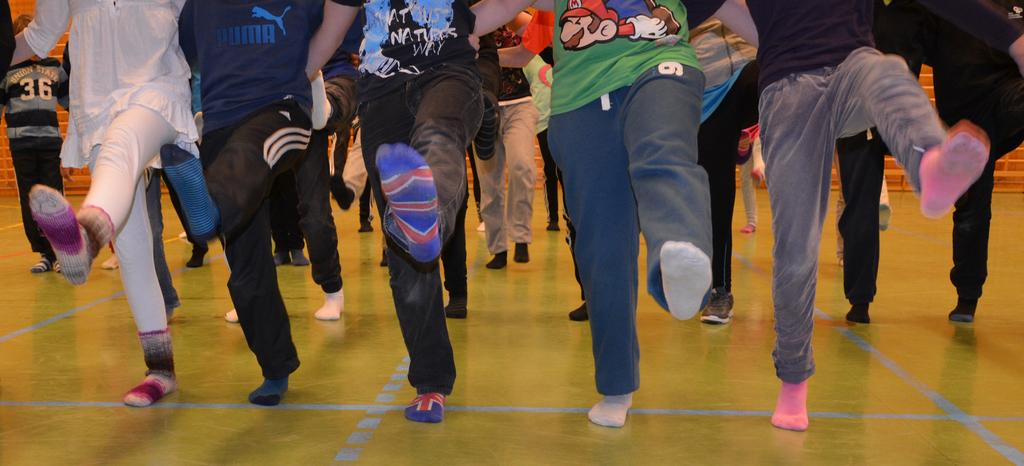What can be seen in the image related to people? There are legs of people visible in the image, and they are in motion. What else can be observed about the people in the image? There are people standing in the background of the image. What is visible in the background of the image? There is a brick wall in the background of the image. What type of shop can be seen in the image? There is no shop present in the image. How do the people in the image react to the bubble? There is no bubble present in the image, so it is not possible to determine how the people might react to it. 